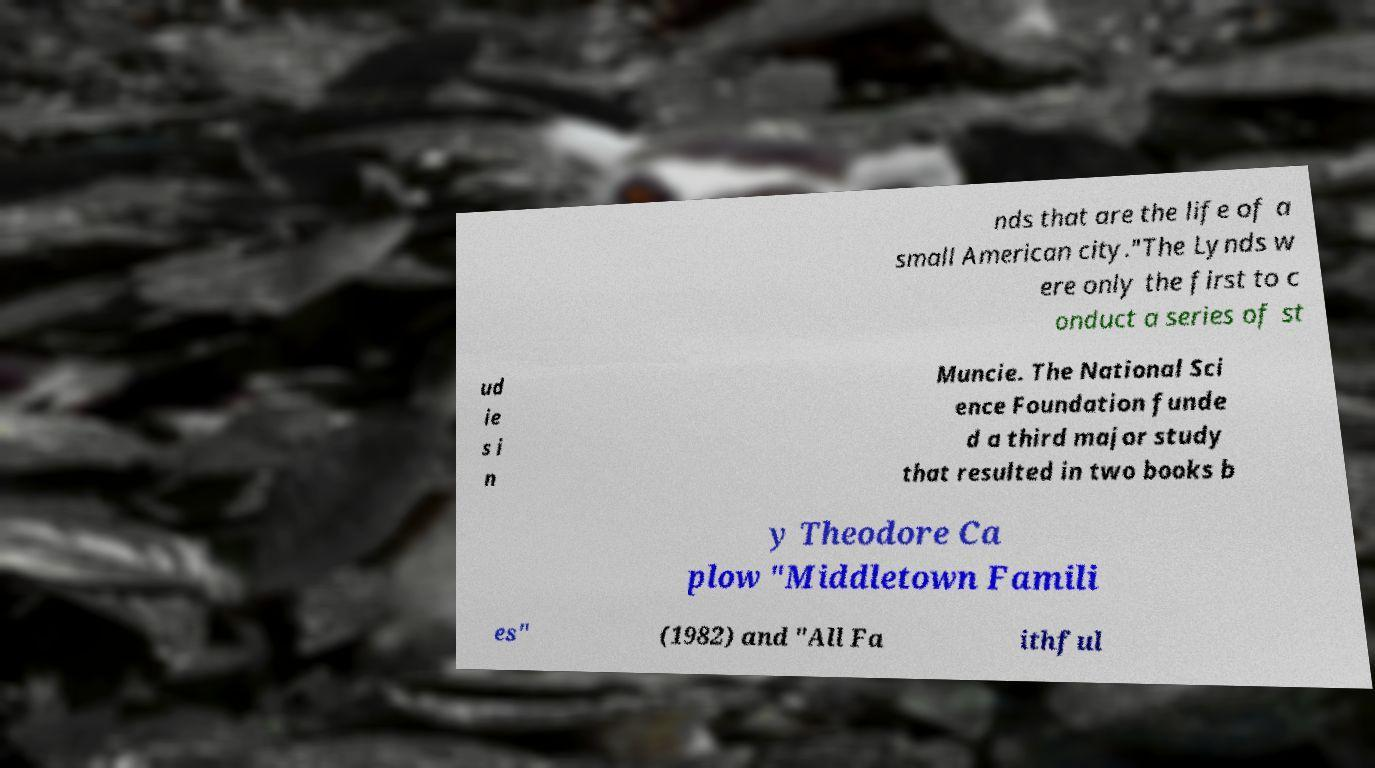I need the written content from this picture converted into text. Can you do that? nds that are the life of a small American city."The Lynds w ere only the first to c onduct a series of st ud ie s i n Muncie. The National Sci ence Foundation funde d a third major study that resulted in two books b y Theodore Ca plow "Middletown Famili es" (1982) and "All Fa ithful 